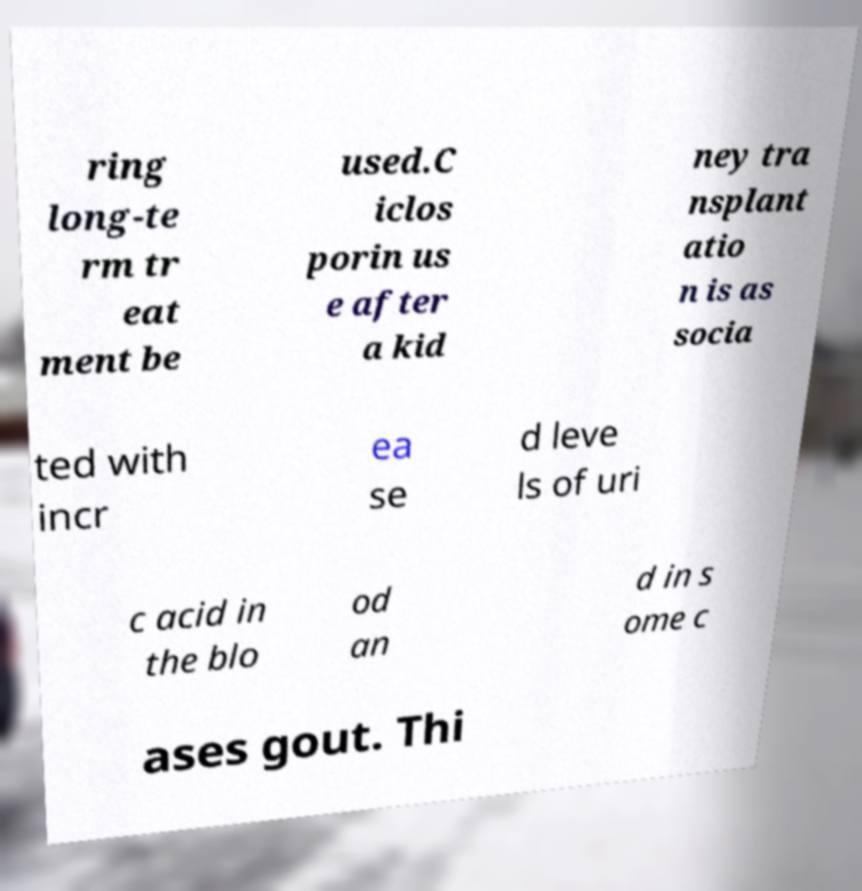I need the written content from this picture converted into text. Can you do that? ring long-te rm tr eat ment be used.C iclos porin us e after a kid ney tra nsplant atio n is as socia ted with incr ea se d leve ls of uri c acid in the blo od an d in s ome c ases gout. Thi 